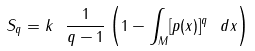Convert formula to latex. <formula><loc_0><loc_0><loc_500><loc_500>S _ { q } = k \ \frac { 1 } { q - 1 } \left ( 1 - \int _ { M } [ p ( x ) ] ^ { q } \ d x \right )</formula> 